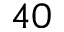<formula> <loc_0><loc_0><loc_500><loc_500>4 0</formula> 